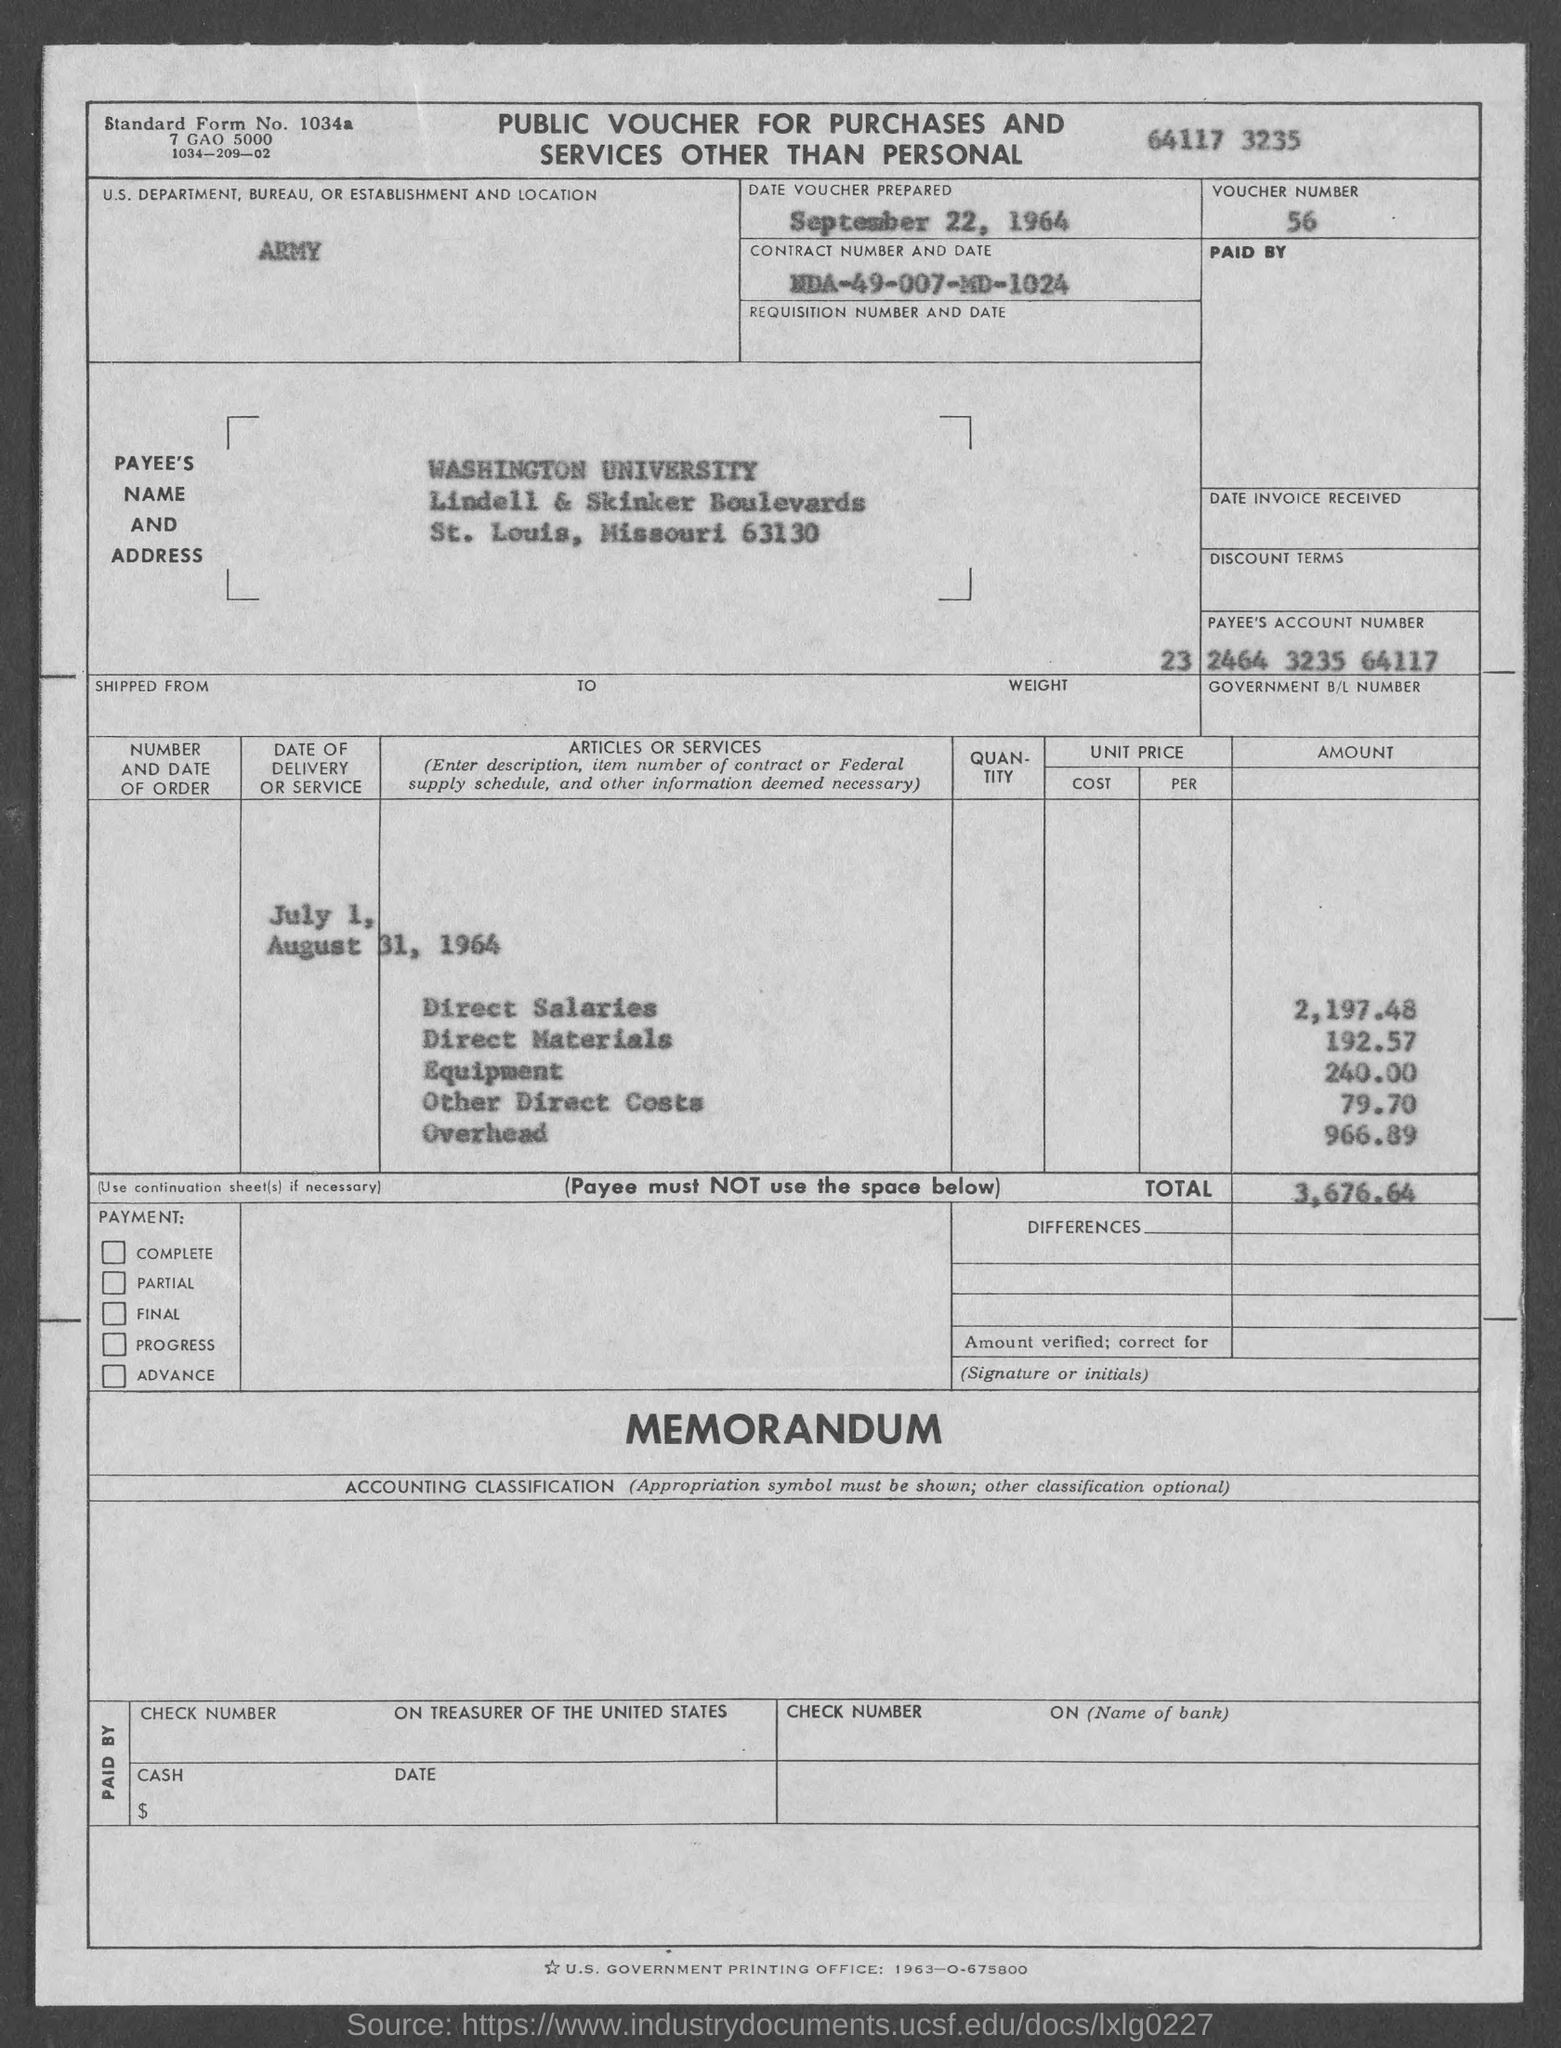What is the address listed for the payee Washington University? The address for Washington University listed on the voucher is Lindell & Skinker Boulevards, St. Louis, Missouri 63130. 